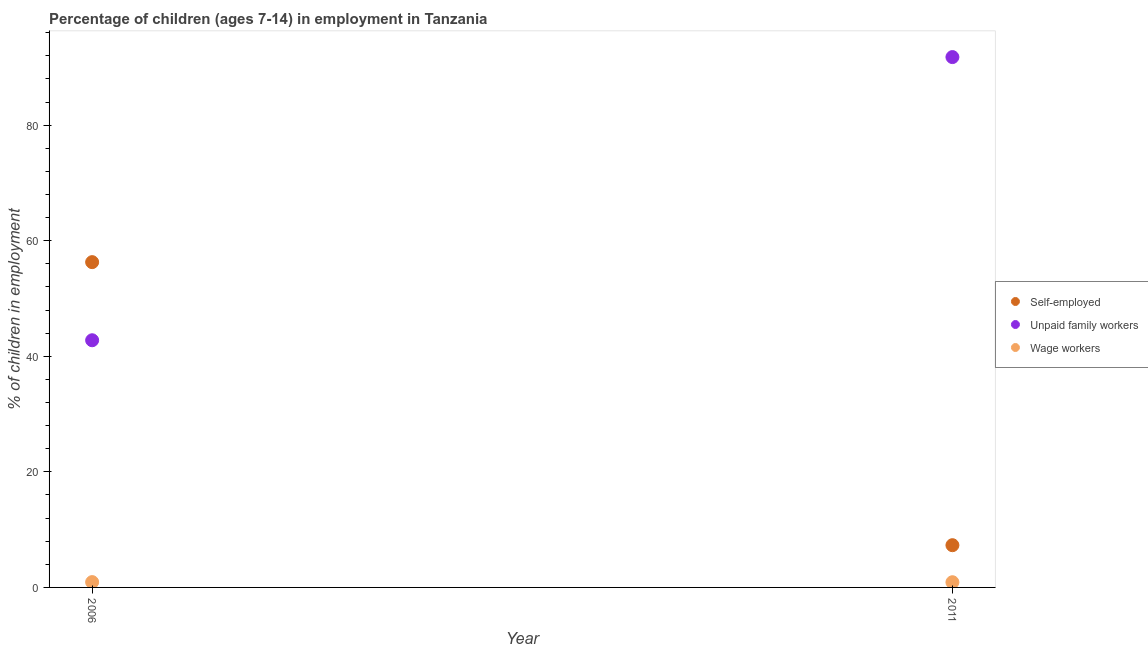How many different coloured dotlines are there?
Ensure brevity in your answer.  3. Across all years, what is the maximum percentage of children employed as unpaid family workers?
Make the answer very short. 91.79. Across all years, what is the minimum percentage of children employed as unpaid family workers?
Your answer should be very brief. 42.78. What is the total percentage of children employed as wage workers in the graph?
Make the answer very short. 1.82. What is the difference between the percentage of self employed children in 2006 and that in 2011?
Your answer should be compact. 48.99. What is the difference between the percentage of children employed as unpaid family workers in 2011 and the percentage of children employed as wage workers in 2006?
Ensure brevity in your answer.  90.87. What is the average percentage of self employed children per year?
Your answer should be very brief. 31.8. In the year 2011, what is the difference between the percentage of children employed as unpaid family workers and percentage of self employed children?
Your response must be concise. 84.48. In how many years, is the percentage of children employed as wage workers greater than 16 %?
Provide a succinct answer. 0. What is the ratio of the percentage of children employed as unpaid family workers in 2006 to that in 2011?
Offer a very short reply. 0.47. In how many years, is the percentage of children employed as unpaid family workers greater than the average percentage of children employed as unpaid family workers taken over all years?
Your response must be concise. 1. Is it the case that in every year, the sum of the percentage of self employed children and percentage of children employed as unpaid family workers is greater than the percentage of children employed as wage workers?
Your response must be concise. Yes. Does the percentage of children employed as unpaid family workers monotonically increase over the years?
Provide a short and direct response. Yes. Is the percentage of children employed as wage workers strictly greater than the percentage of children employed as unpaid family workers over the years?
Offer a terse response. No. How many dotlines are there?
Provide a short and direct response. 3. How many years are there in the graph?
Your response must be concise. 2. Does the graph contain grids?
Your answer should be very brief. No. Where does the legend appear in the graph?
Offer a very short reply. Center right. How many legend labels are there?
Offer a terse response. 3. How are the legend labels stacked?
Give a very brief answer. Vertical. What is the title of the graph?
Provide a succinct answer. Percentage of children (ages 7-14) in employment in Tanzania. Does "Slovak Republic" appear as one of the legend labels in the graph?
Make the answer very short. No. What is the label or title of the Y-axis?
Provide a short and direct response. % of children in employment. What is the % of children in employment of Self-employed in 2006?
Make the answer very short. 56.3. What is the % of children in employment in Unpaid family workers in 2006?
Keep it short and to the point. 42.78. What is the % of children in employment in Wage workers in 2006?
Your answer should be very brief. 0.92. What is the % of children in employment in Self-employed in 2011?
Your answer should be very brief. 7.31. What is the % of children in employment in Unpaid family workers in 2011?
Offer a very short reply. 91.79. What is the % of children in employment of Wage workers in 2011?
Your answer should be compact. 0.9. Across all years, what is the maximum % of children in employment in Self-employed?
Give a very brief answer. 56.3. Across all years, what is the maximum % of children in employment in Unpaid family workers?
Provide a succinct answer. 91.79. Across all years, what is the minimum % of children in employment in Self-employed?
Your answer should be very brief. 7.31. Across all years, what is the minimum % of children in employment in Unpaid family workers?
Provide a short and direct response. 42.78. What is the total % of children in employment of Self-employed in the graph?
Your response must be concise. 63.61. What is the total % of children in employment in Unpaid family workers in the graph?
Make the answer very short. 134.57. What is the total % of children in employment of Wage workers in the graph?
Provide a short and direct response. 1.82. What is the difference between the % of children in employment of Self-employed in 2006 and that in 2011?
Make the answer very short. 48.99. What is the difference between the % of children in employment of Unpaid family workers in 2006 and that in 2011?
Make the answer very short. -49.01. What is the difference between the % of children in employment in Wage workers in 2006 and that in 2011?
Provide a short and direct response. 0.02. What is the difference between the % of children in employment in Self-employed in 2006 and the % of children in employment in Unpaid family workers in 2011?
Provide a short and direct response. -35.49. What is the difference between the % of children in employment of Self-employed in 2006 and the % of children in employment of Wage workers in 2011?
Offer a terse response. 55.4. What is the difference between the % of children in employment in Unpaid family workers in 2006 and the % of children in employment in Wage workers in 2011?
Offer a terse response. 41.88. What is the average % of children in employment in Self-employed per year?
Keep it short and to the point. 31.8. What is the average % of children in employment in Unpaid family workers per year?
Make the answer very short. 67.28. What is the average % of children in employment of Wage workers per year?
Offer a very short reply. 0.91. In the year 2006, what is the difference between the % of children in employment in Self-employed and % of children in employment in Unpaid family workers?
Your answer should be compact. 13.52. In the year 2006, what is the difference between the % of children in employment in Self-employed and % of children in employment in Wage workers?
Your response must be concise. 55.38. In the year 2006, what is the difference between the % of children in employment in Unpaid family workers and % of children in employment in Wage workers?
Offer a terse response. 41.86. In the year 2011, what is the difference between the % of children in employment in Self-employed and % of children in employment in Unpaid family workers?
Your answer should be very brief. -84.48. In the year 2011, what is the difference between the % of children in employment of Self-employed and % of children in employment of Wage workers?
Offer a terse response. 6.41. In the year 2011, what is the difference between the % of children in employment in Unpaid family workers and % of children in employment in Wage workers?
Make the answer very short. 90.89. What is the ratio of the % of children in employment of Self-employed in 2006 to that in 2011?
Your answer should be very brief. 7.7. What is the ratio of the % of children in employment of Unpaid family workers in 2006 to that in 2011?
Provide a short and direct response. 0.47. What is the ratio of the % of children in employment of Wage workers in 2006 to that in 2011?
Keep it short and to the point. 1.02. What is the difference between the highest and the second highest % of children in employment in Self-employed?
Your answer should be compact. 48.99. What is the difference between the highest and the second highest % of children in employment in Unpaid family workers?
Offer a terse response. 49.01. What is the difference between the highest and the lowest % of children in employment of Self-employed?
Make the answer very short. 48.99. What is the difference between the highest and the lowest % of children in employment of Unpaid family workers?
Offer a terse response. 49.01. What is the difference between the highest and the lowest % of children in employment in Wage workers?
Make the answer very short. 0.02. 